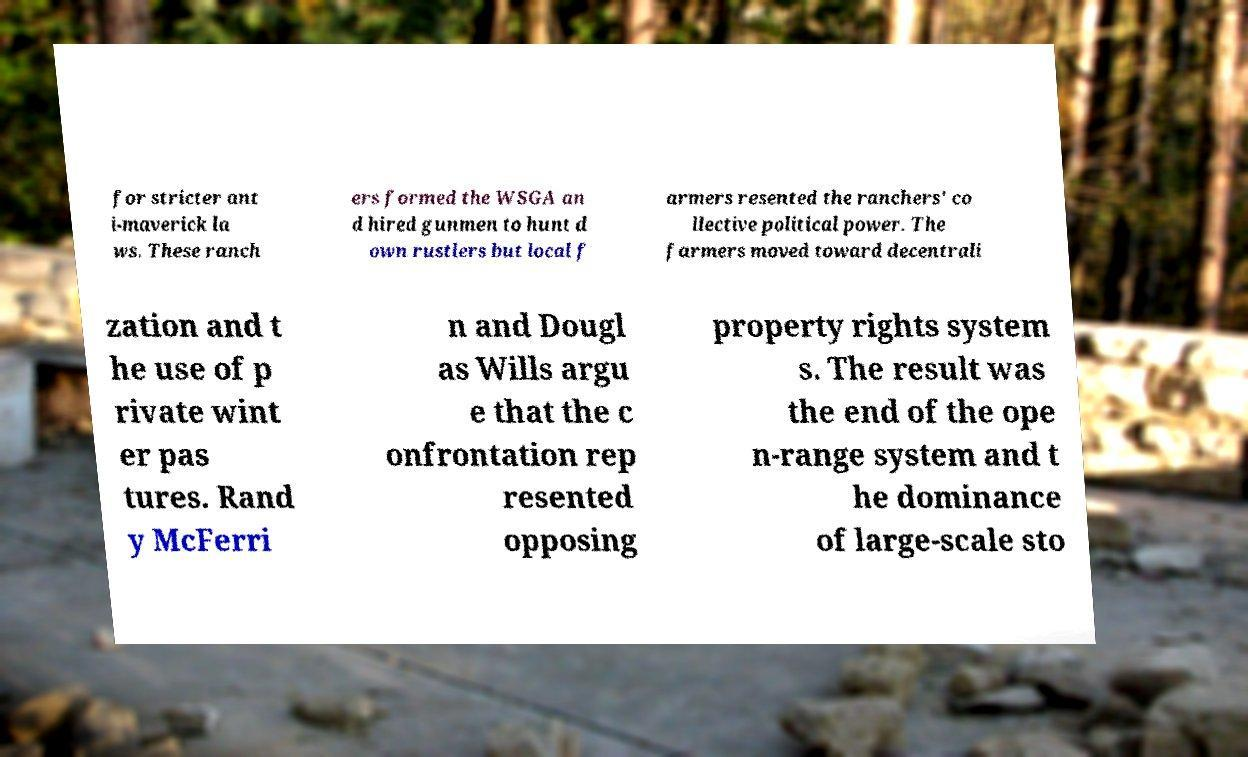There's text embedded in this image that I need extracted. Can you transcribe it verbatim? for stricter ant i-maverick la ws. These ranch ers formed the WSGA an d hired gunmen to hunt d own rustlers but local f armers resented the ranchers' co llective political power. The farmers moved toward decentrali zation and t he use of p rivate wint er pas tures. Rand y McFerri n and Dougl as Wills argu e that the c onfrontation rep resented opposing property rights system s. The result was the end of the ope n-range system and t he dominance of large-scale sto 